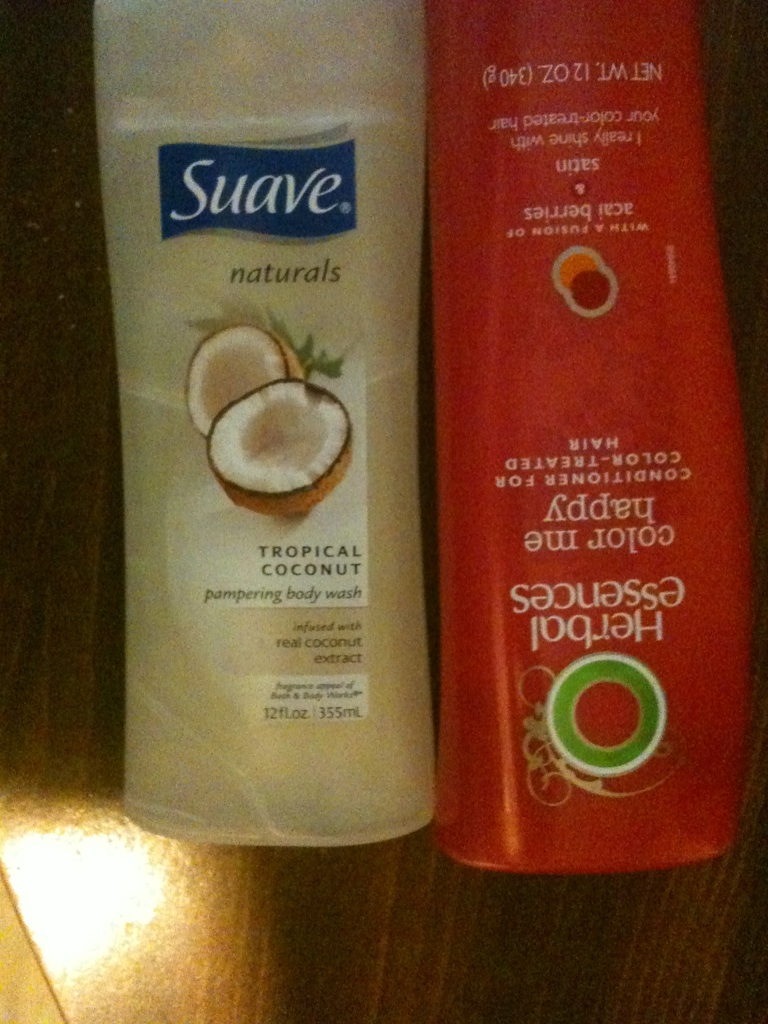Can you please tell me what's in these two bottles? The bottles contain Suave Tropical Coconut Pampering Body Wash and Herbal Essences Color Me Happy Conditioner. The body wash is infused with real coconut extract and is designed to pamper your skin, leaving it soft and smooth. The conditioner is tailored for color-treated hair, ensuring vibrant shine and protection. 